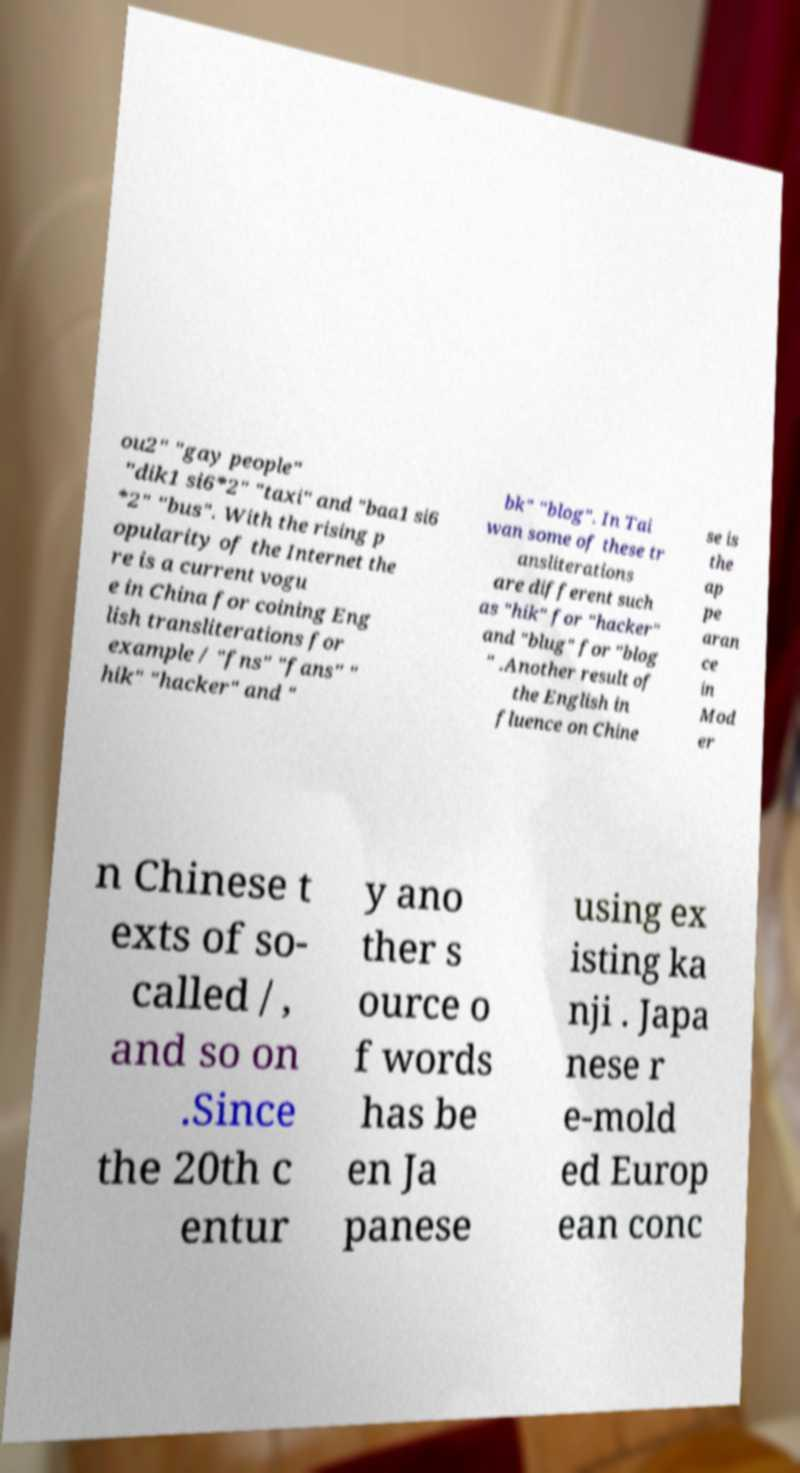Could you assist in decoding the text presented in this image and type it out clearly? ou2" "gay people" "dik1 si6*2" "taxi" and "baa1 si6 *2" "bus". With the rising p opularity of the Internet the re is a current vogu e in China for coining Eng lish transliterations for example / "fns" "fans" " hik" "hacker" and " bk" "blog". In Tai wan some of these tr ansliterations are different such as "hik" for "hacker" and "blug" for "blog " .Another result of the English in fluence on Chine se is the ap pe aran ce in Mod er n Chinese t exts of so- called / , and so on .Since the 20th c entur y ano ther s ource o f words has be en Ja panese using ex isting ka nji . Japa nese r e-mold ed Europ ean conc 